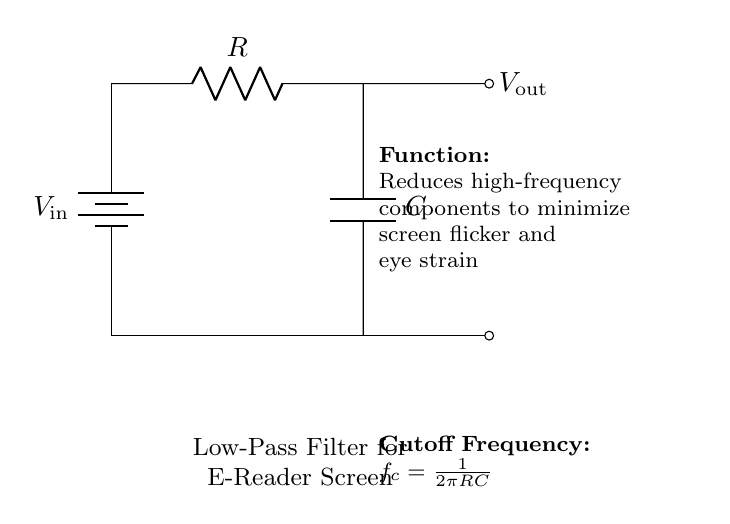What type of filter is represented in this circuit? The circuit diagram shows a low-pass filter that allows low-frequency signals to pass while attenuating higher frequency signals. The notation in the circuit explicitly names it as a "Low-Pass Filter."
Answer: Low-pass filter What are the two main components used in this circuit? The circuit consists of a resistor and a capacitor. The resistor is labeled as "R" and the capacitor is labeled as "C." These components are essential for the function of the filter.
Answer: Resistor and capacitor What does the output voltage represent in this circuit? The output voltage, labeled as "V_out," represents the voltage across the capacitor, which is the filtered voltage that reduces high-frequency noise from the input voltage.
Answer: V_out What is the purpose of this low-pass filter? The purpose of this low-pass filter is to reduce high-frequency components from the input signal, which minimizes screen flicker and helps reduce eye strain when using e-reader devices.
Answer: Minimize eye strain What is the formula for the cutoff frequency of this filter? The cutoff frequency is given by the formula "f_c = 1/(2πRC)," where R is the resistance and C is the capacitance. This formula determines the frequency at which the filter will start to attenuate higher frequencies.
Answer: f_c = 1/(2πRC) Why is the cutoff frequency important in this circuit? The cutoff frequency is critical because it defines the threshold beyond which the filter starts to attenuate signals. Selecting the correct cutoff frequency ensures that the filter effectively reduces screen flicker while allowing lower frequencies essential for display functionality to pass through.
Answer: It defines the frequency threshold 